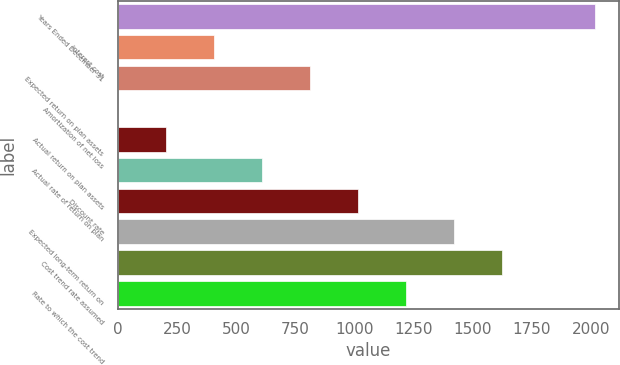<chart> <loc_0><loc_0><loc_500><loc_500><bar_chart><fcel>Years Ended December 31<fcel>Interest cost<fcel>Expected return on plan assets<fcel>Amortization of net loss<fcel>Actual return on plan assets<fcel>Actual rate of return on plan<fcel>Discount rate<fcel>Expected long-term return on<fcel>Cost trend rate assumed<fcel>Rate to which the cost trend<nl><fcel>2018<fcel>406.2<fcel>811.4<fcel>1<fcel>203.6<fcel>608.8<fcel>1014<fcel>1419.2<fcel>1621.8<fcel>1216.6<nl></chart> 